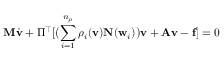Convert formula to latex. <formula><loc_0><loc_0><loc_500><loc_500>{ M } \dot { { v } } + \Pi ^ { \top } [ \left ( \sum _ { i = 1 } ^ { n _ { \rho } } \rho _ { i } ( { v } ) { N } ( { w } _ { i } ) \right ) { v } + { A } { v } - { f } ] = 0</formula> 